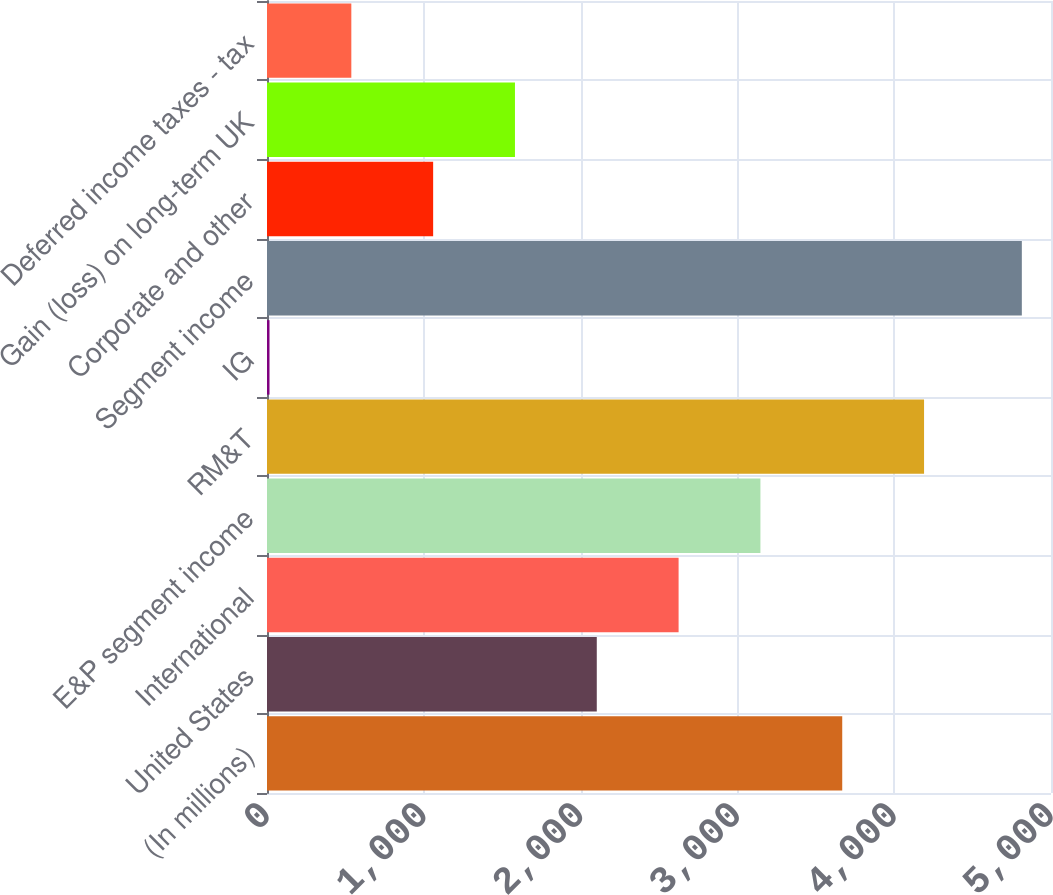Convert chart to OTSL. <chart><loc_0><loc_0><loc_500><loc_500><bar_chart><fcel>(In millions)<fcel>United States<fcel>International<fcel>E&P segment income<fcel>RM&T<fcel>IG<fcel>Segment income<fcel>Corporate and other<fcel>Gain (loss) on long-term UK<fcel>Deferred income taxes - tax<nl><fcel>3668.6<fcel>2103.2<fcel>2625<fcel>3146.8<fcel>4190.4<fcel>16<fcel>4814<fcel>1059.6<fcel>1581.4<fcel>537.8<nl></chart> 